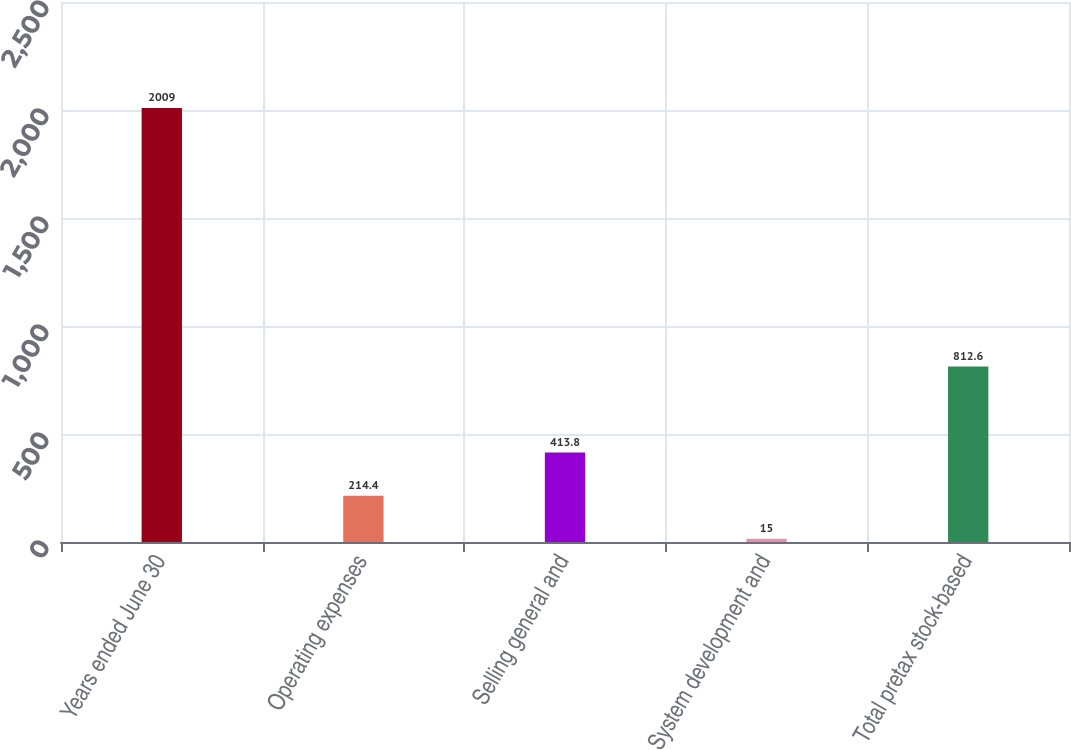Convert chart. <chart><loc_0><loc_0><loc_500><loc_500><bar_chart><fcel>Years ended June 30<fcel>Operating expenses<fcel>Selling general and<fcel>System development and<fcel>Total pretax stock-based<nl><fcel>2009<fcel>214.4<fcel>413.8<fcel>15<fcel>812.6<nl></chart> 